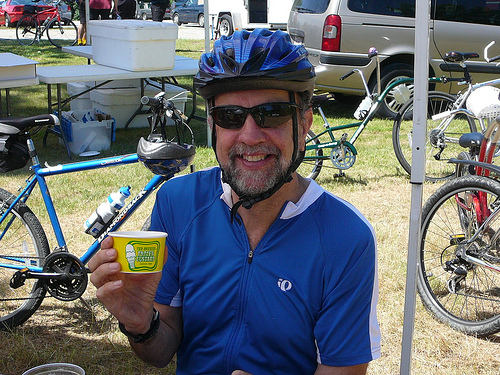How many people are in the photo? There is 1 person visible in the photo, a smiling man wearing a helmet and cycling apparel, holding up a small tin or packet. 